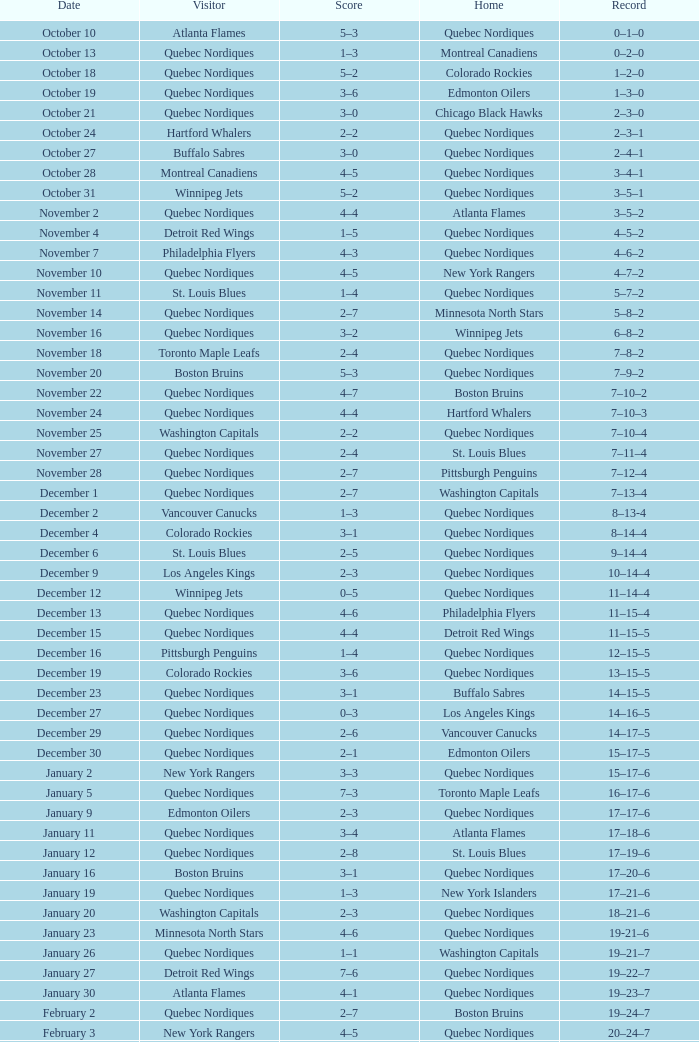Which Home has a Record of 16–17–6? Toronto Maple Leafs. 